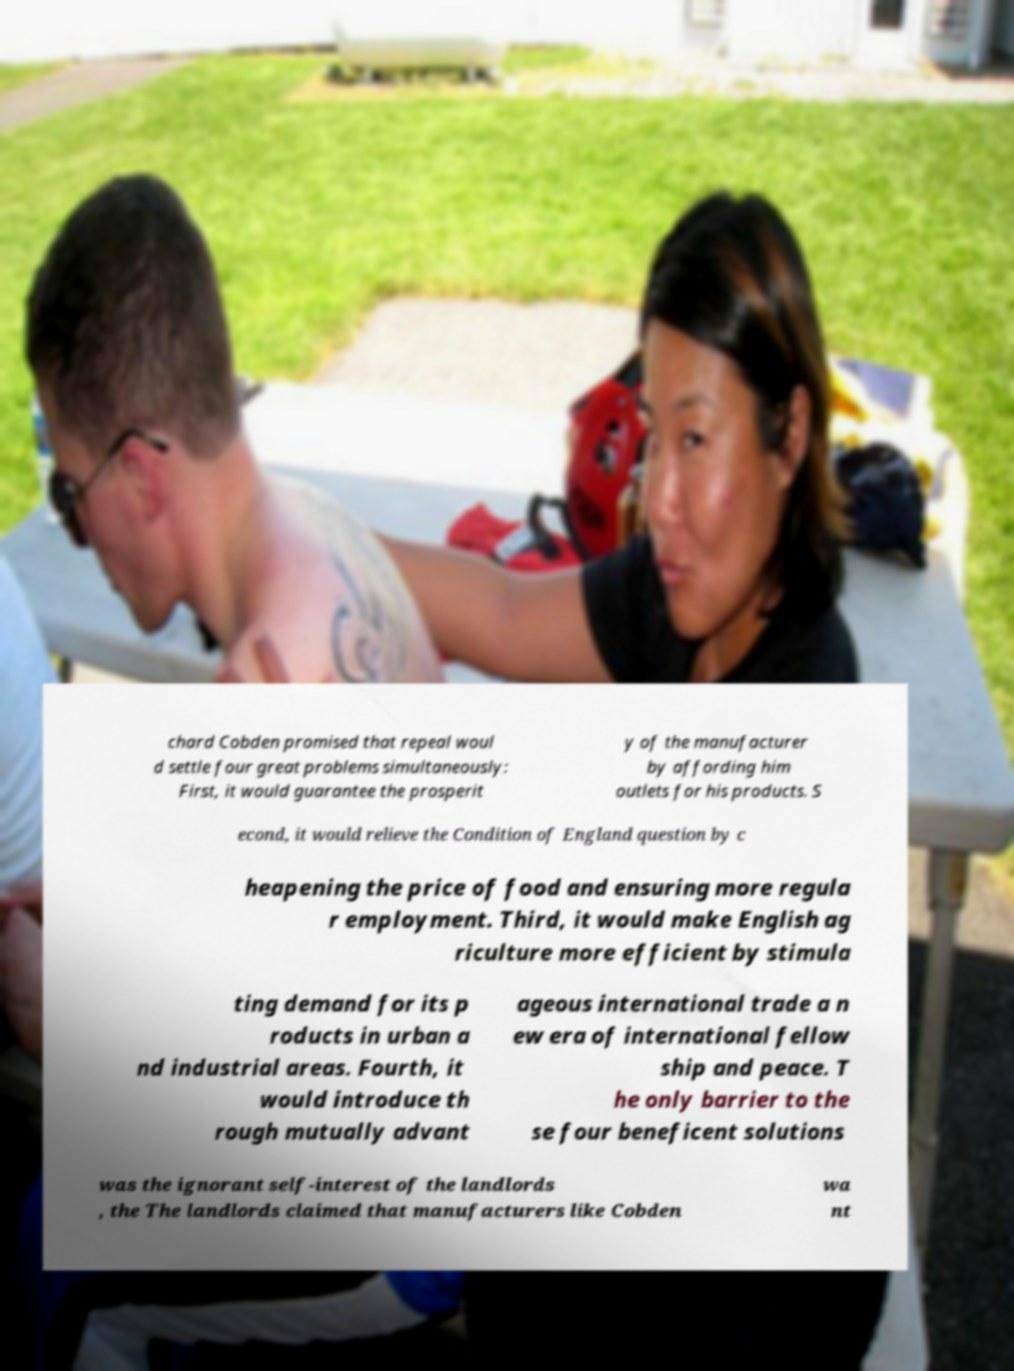For documentation purposes, I need the text within this image transcribed. Could you provide that? chard Cobden promised that repeal woul d settle four great problems simultaneously: First, it would guarantee the prosperit y of the manufacturer by affording him outlets for his products. S econd, it would relieve the Condition of England question by c heapening the price of food and ensuring more regula r employment. Third, it would make English ag riculture more efficient by stimula ting demand for its p roducts in urban a nd industrial areas. Fourth, it would introduce th rough mutually advant ageous international trade a n ew era of international fellow ship and peace. T he only barrier to the se four beneficent solutions was the ignorant self-interest of the landlords , the The landlords claimed that manufacturers like Cobden wa nt 